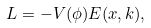<formula> <loc_0><loc_0><loc_500><loc_500>L = - V ( \phi ) E ( x , k ) ,</formula> 